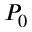<formula> <loc_0><loc_0><loc_500><loc_500>P _ { 0 }</formula> 